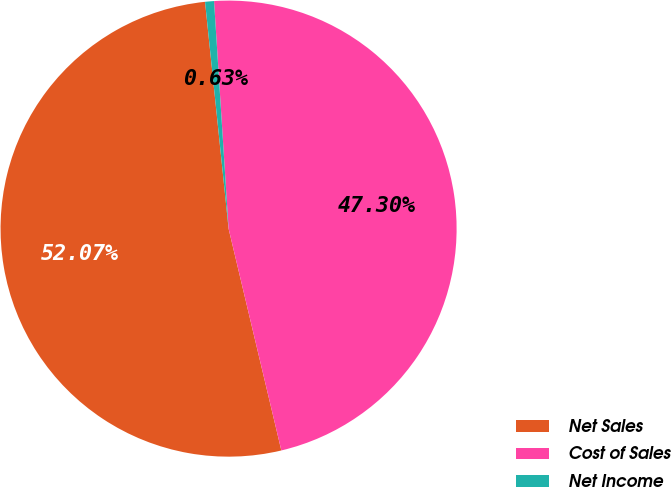Convert chart to OTSL. <chart><loc_0><loc_0><loc_500><loc_500><pie_chart><fcel>Net Sales<fcel>Cost of Sales<fcel>Net Income<nl><fcel>52.07%<fcel>47.3%<fcel>0.63%<nl></chart> 